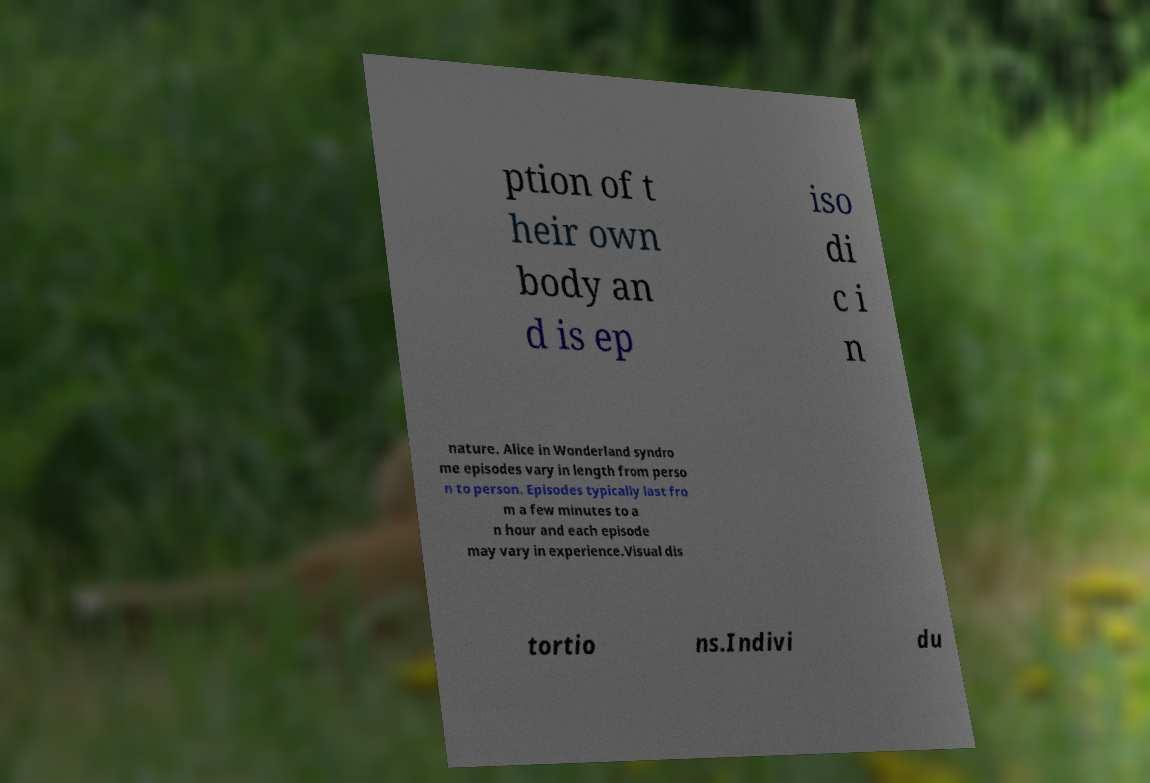Can you read and provide the text displayed in the image?This photo seems to have some interesting text. Can you extract and type it out for me? ption of t heir own body an d is ep iso di c i n nature. Alice in Wonderland syndro me episodes vary in length from perso n to person. Episodes typically last fro m a few minutes to a n hour and each episode may vary in experience.Visual dis tortio ns.Indivi du 